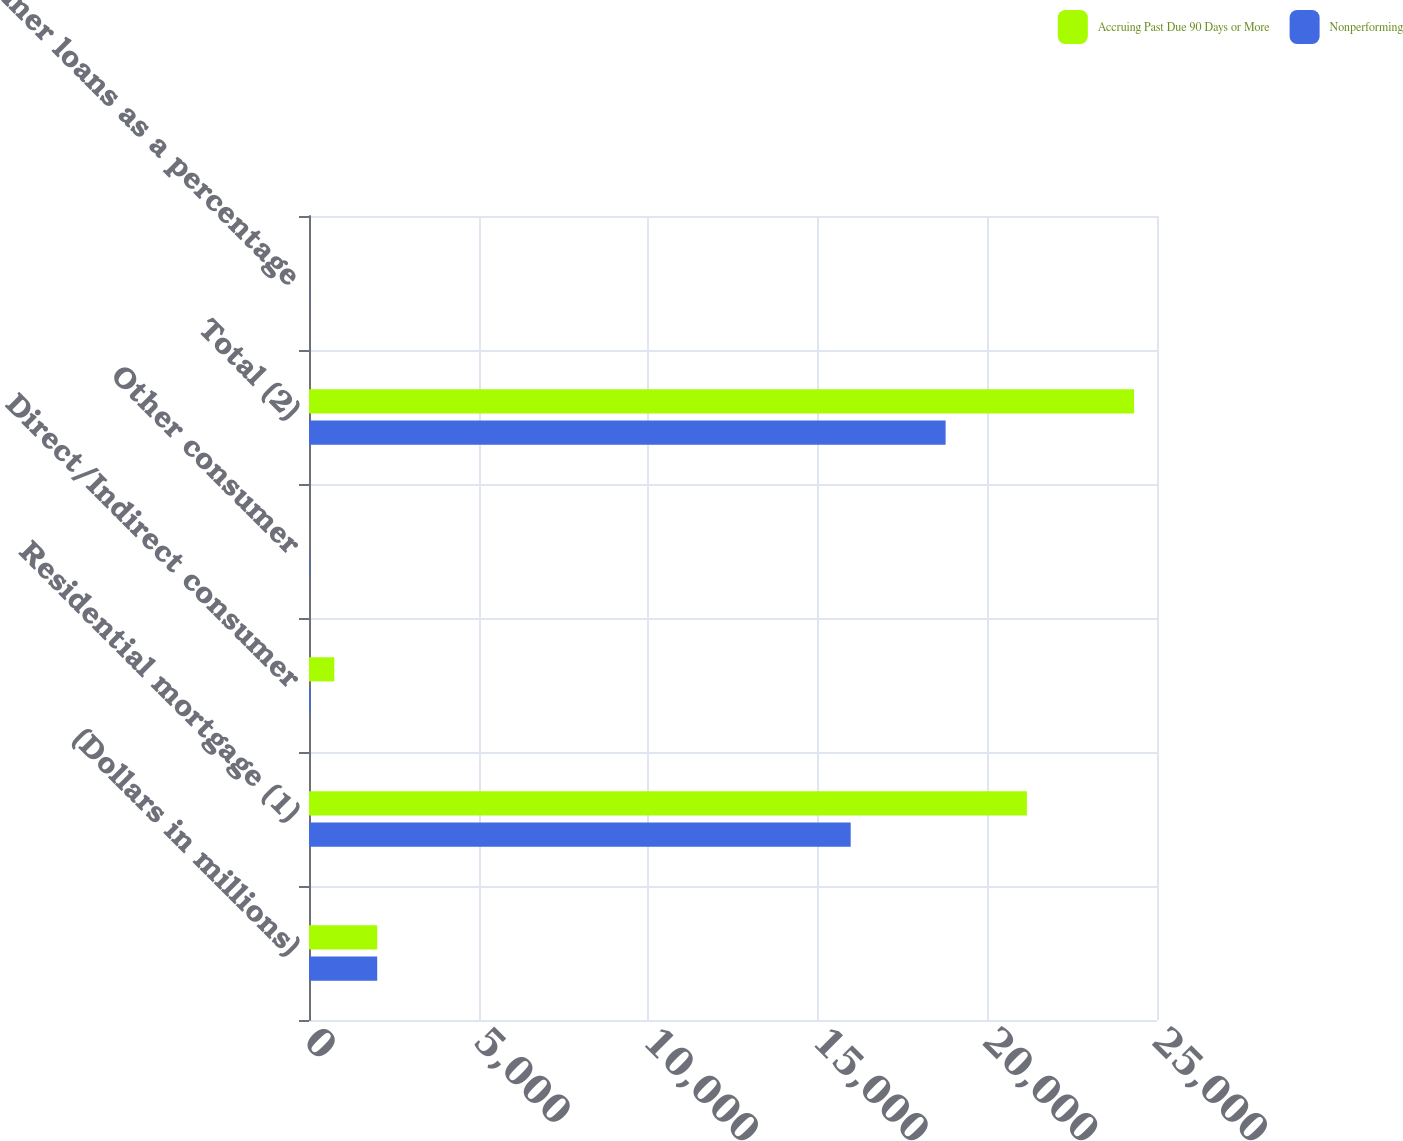Convert chart to OTSL. <chart><loc_0><loc_0><loc_500><loc_500><stacked_bar_chart><ecel><fcel>(Dollars in millions)<fcel>Residential mortgage (1)<fcel>Direct/Indirect consumer<fcel>Other consumer<fcel>Total (2)<fcel>Consumer loans as a percentage<nl><fcel>Accruing Past Due 90 Days or More<fcel>2011<fcel>21164<fcel>746<fcel>2<fcel>24324<fcel>0.66<nl><fcel>Nonperforming<fcel>2011<fcel>15970<fcel>40<fcel>15<fcel>18768<fcel>3.9<nl></chart> 